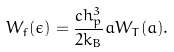<formula> <loc_0><loc_0><loc_500><loc_500>W _ { f } ( \epsilon ) = \frac { c h _ { p } ^ { 3 } } { 2 k _ { B } } a W _ { T } ( a ) .</formula> 